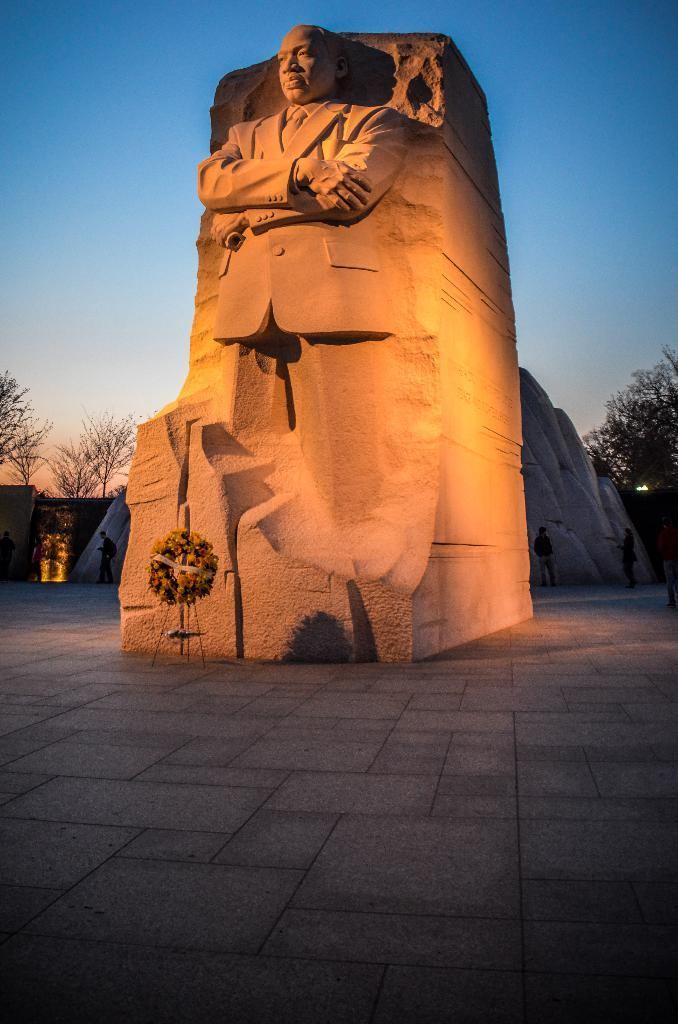What is the main subject of the image? There is a statue of a man in the image. What type of natural elements can be seen in the image? Rocks, trees, and flowers garland are visible in the image. Are there any people present in the image? Yes, there are people standing on the ground in the image. What is visible in the background of the image? The sky is visible in the background of the image. Can you tell me how the cub is playing with the motion detector in the image? There is no cub or motion detector present in the image. What type of motion is the statue performing in the image? The statue is not performing any motion in the image; it is a stationary object. 